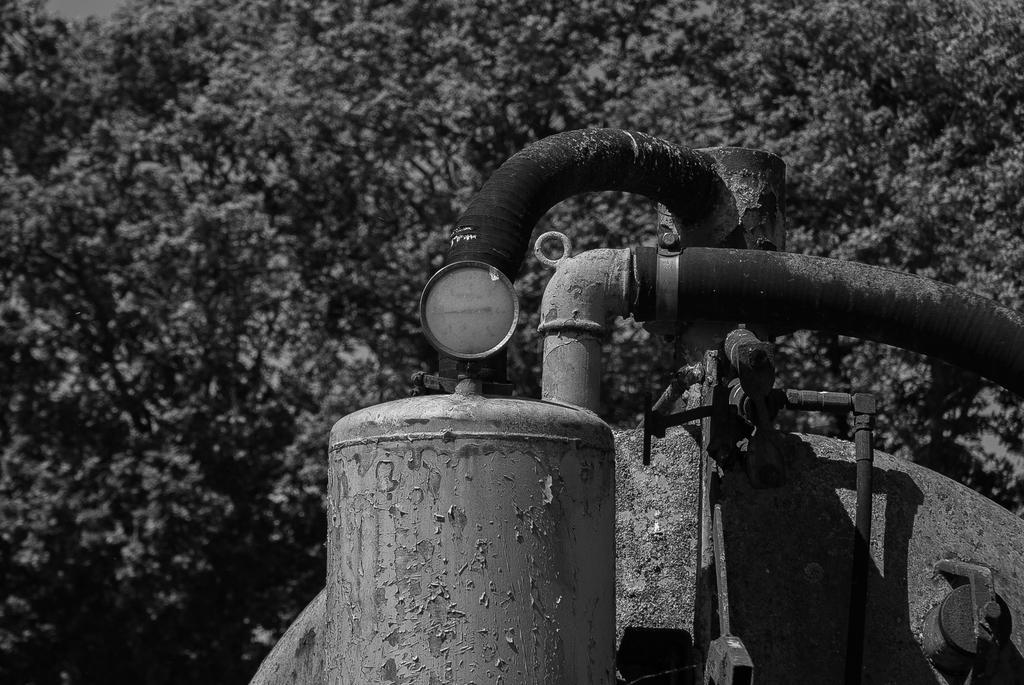What is the main object in the image? There is a motor in the image. What can be seen in the background of the image? There are trees behind the motor in the image. Can you see the tail of the motor in the image? There is no tail present on the motor in the image. Is the motor located near the seashore in the image? The image does not show any seashore or water body; it only features a motor and trees. 